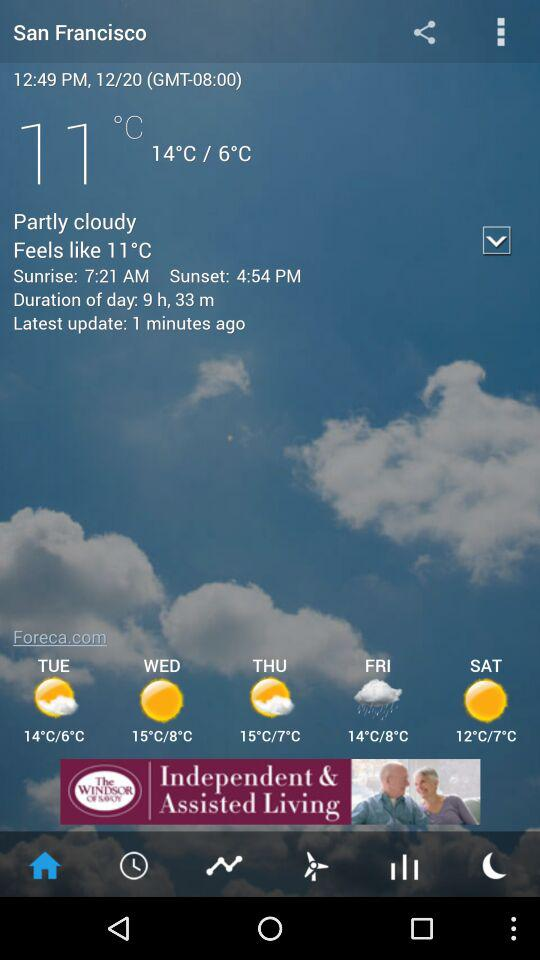What is the duration of the day? The duration of the day as displayed in the image for San Francisco on the specific date shown is 9 hours and 33 minutes; this value will vary throughout the year due to the changing position of the Earth in relation to the Sun. 